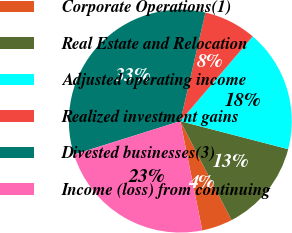Convert chart. <chart><loc_0><loc_0><loc_500><loc_500><pie_chart><fcel>Corporate Operations(1)<fcel>Real Estate and Relocation<fcel>Adjusted operating income<fcel>Realized investment gains<fcel>Divested businesses(3)<fcel>Income (loss) from continuing<nl><fcel>4.45%<fcel>13.35%<fcel>17.8%<fcel>7.63%<fcel>33.47%<fcel>23.31%<nl></chart> 